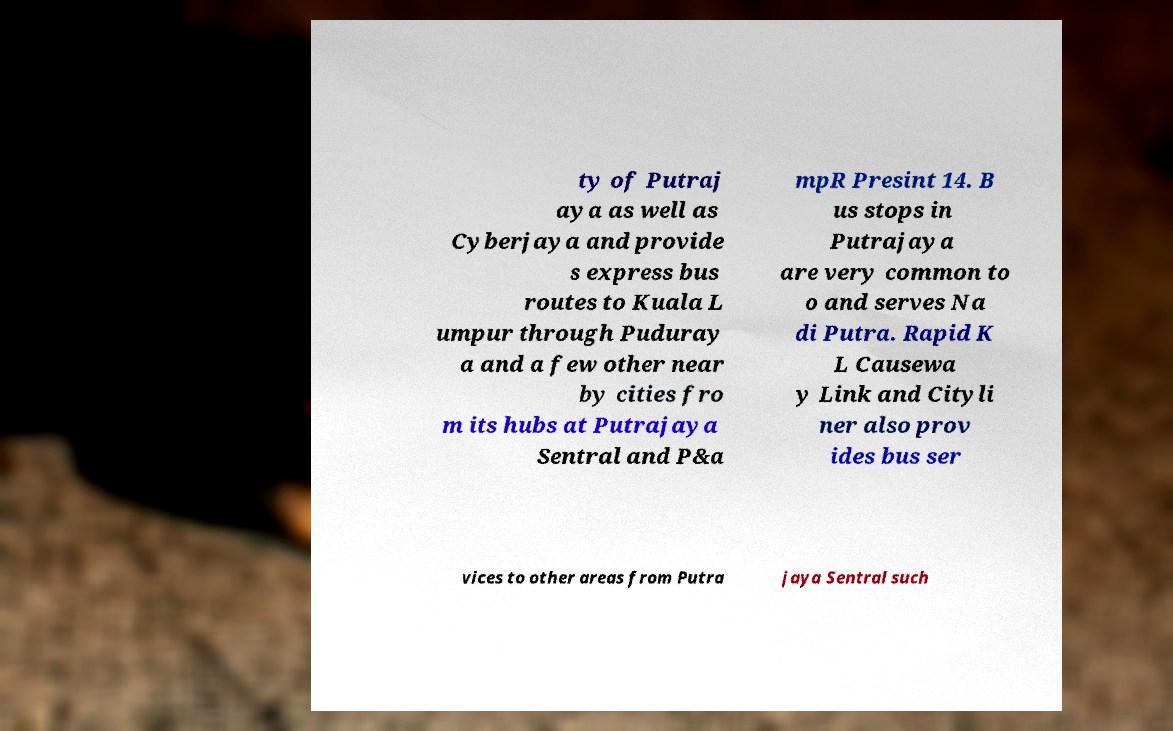Could you extract and type out the text from this image? ty of Putraj aya as well as Cyberjaya and provide s express bus routes to Kuala L umpur through Puduray a and a few other near by cities fro m its hubs at Putrajaya Sentral and P&a mpR Presint 14. B us stops in Putrajaya are very common to o and serves Na di Putra. Rapid K L Causewa y Link and Cityli ner also prov ides bus ser vices to other areas from Putra jaya Sentral such 